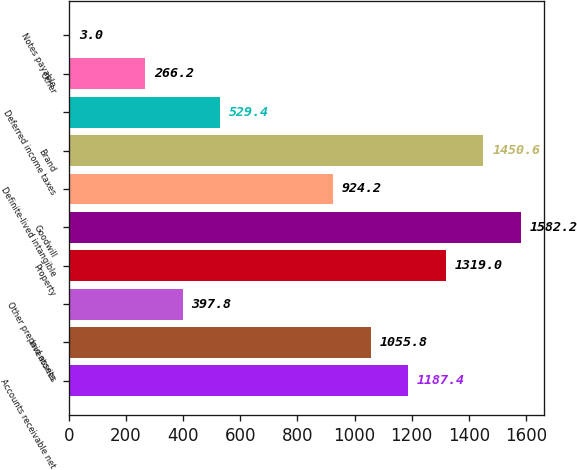Convert chart. <chart><loc_0><loc_0><loc_500><loc_500><bar_chart><fcel>Accounts receivable net<fcel>Inventories<fcel>Other prepaid assets<fcel>Property<fcel>Goodwill<fcel>Definite-lived intangible<fcel>Brand<fcel>Deferred income taxes<fcel>Other<fcel>Notes payable<nl><fcel>1187.4<fcel>1055.8<fcel>397.8<fcel>1319<fcel>1582.2<fcel>924.2<fcel>1450.6<fcel>529.4<fcel>266.2<fcel>3<nl></chart> 